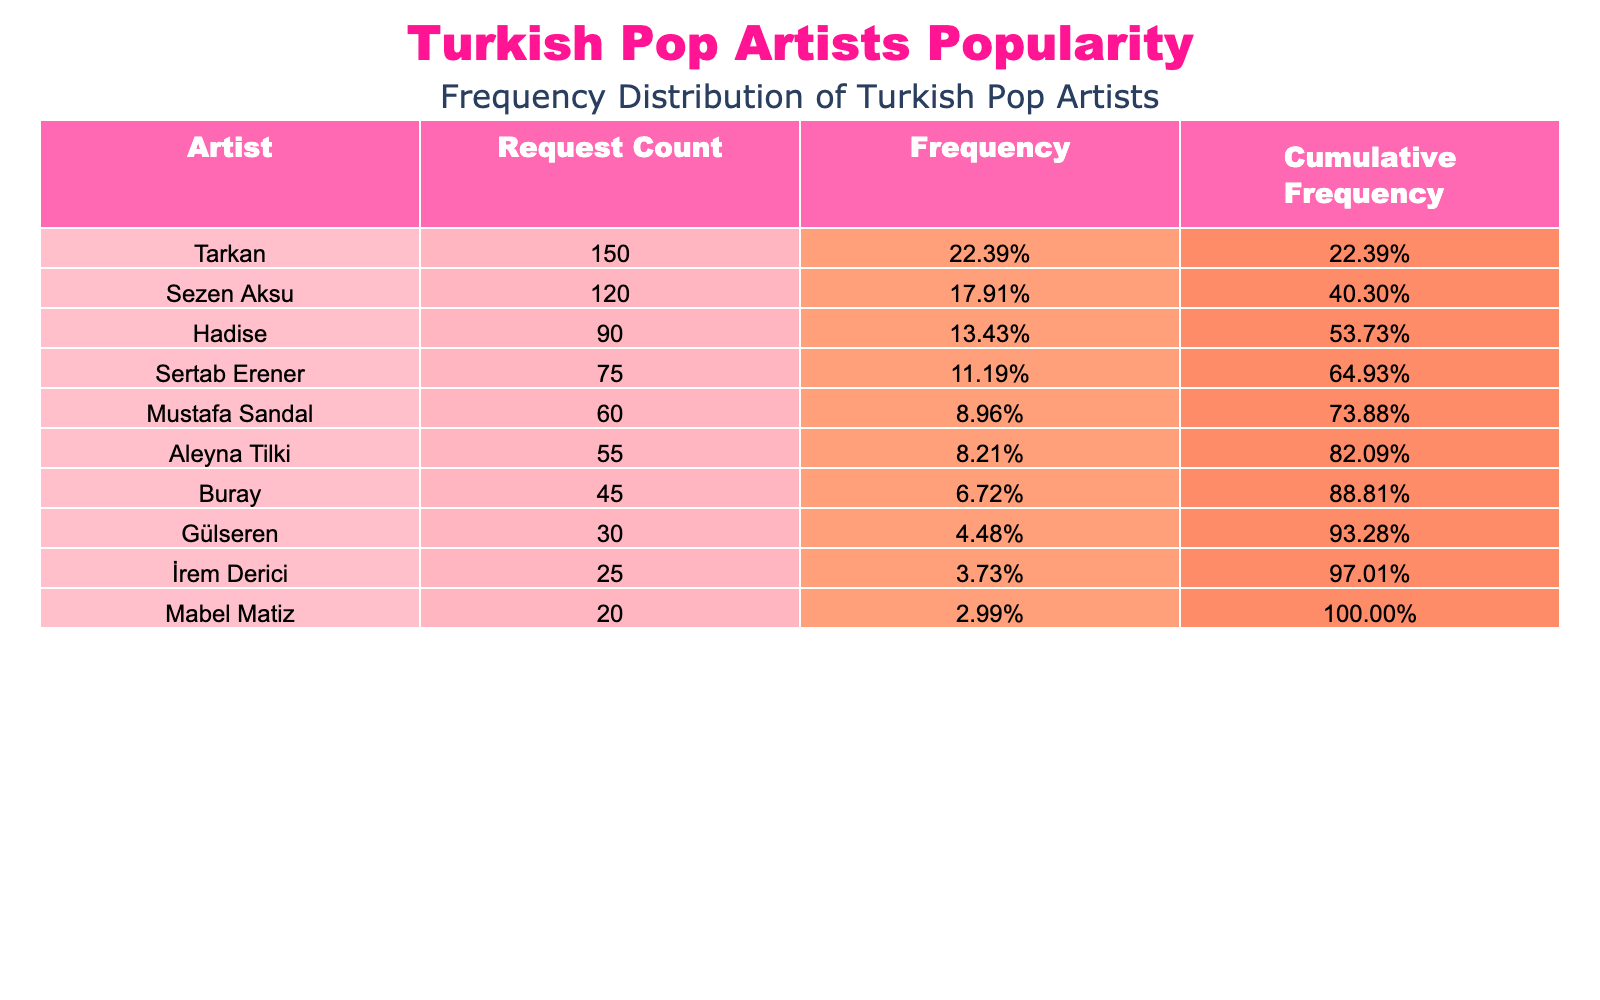What is the total number of requests for all artists? To find the total number of requests, we sum the Request_Count for all artists. The total is calculated as 150 + 120 + 90 + 75 + 60 + 55 + 45 + 30 + 25 + 20 = 720.
Answer: 720 Which artist received the most requests? Looking at the Request_Count column, Tarkan has the highest value with 150 requests, more than any other artist.
Answer: Tarkan What is the frequency of Hadise? To find Hadise's frequency, divide her Request_Count (90) by the total number of requests (720). Thus, the frequency is 90 / 720 = 0.125 or 12.5%.
Answer: 12.5% What is the cumulative frequency for the artist with the second-highest requests? The second artist by Request_Count is Sezen Aksu with 120 requests. To find the cumulative frequency, we add the frequencies of Tarkan (150) and Sezen Aksu (120). First, calculate frequency for Tarkan (150 / 720 = 0.2083) and Sezen Aksu (120 / 720 = 0.1667). The cumulative frequency is 0.2083 + 0.1667 = 0.375 or 37.5%.
Answer: 37.5% Is Aleyna Tilki among the top three most requested artists? Checking the Request_Count column, Aleyna Tilki has 55 requests which places her at the 6th position, so she is not in the top three artists.
Answer: No What is the difference in request counts between the most and least popular artists? The most popular artist is Tarkan with 150 requests and the least popular artist is Mabel Matiz with 20 requests. The difference is 150 - 20 = 130.
Answer: 130 What percentage of total requests does Sertab Erener represent? To find Sertab Erener's percentage, we divide his Request_Count of 75 by the total of 720 and then multiply by 100. So, (75 / 720) * 100 = 10.42%.
Answer: 10.42% Who are the artists with a request count of more than 70? Looking at the Request_Count, the artists with more than 70 requests are Tarkan (150), Sezen Aksu (120), Hadise (90), and Sertab Erener (75).
Answer: Tarkan, Sezen Aksu, Hadise, Sertab Erener What is the average request count for all artists listed? To find the average, we take the total request count (720) and divide by the number of artists (10). Thus, 720 / 10 = 72.
Answer: 72 